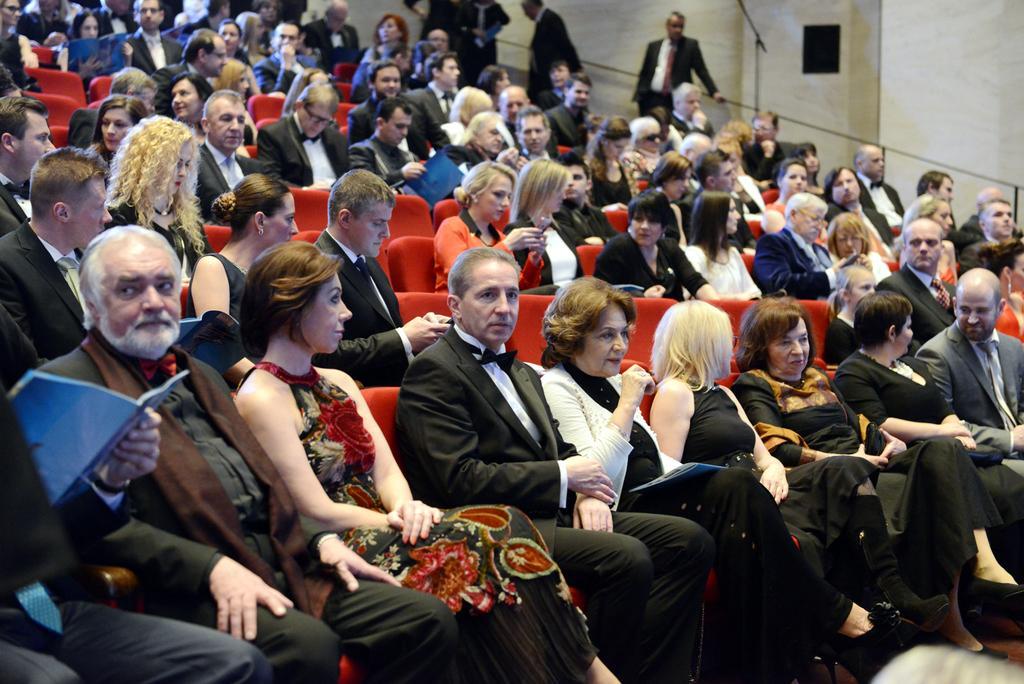Can you describe this image briefly? This picture describes about group of people, few are seated on the chairs and few are standing, on the left side of the image we can find a person and he is holding a book, in the background we can find few metal rods. 